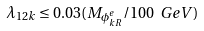Convert formula to latex. <formula><loc_0><loc_0><loc_500><loc_500>\lambda _ { 1 2 k } \leq 0 . 0 3 ( M _ { \phi _ { k R } ^ { e } } / 1 0 0 \ G e V )</formula> 